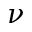Convert formula to latex. <formula><loc_0><loc_0><loc_500><loc_500>\nu</formula> 